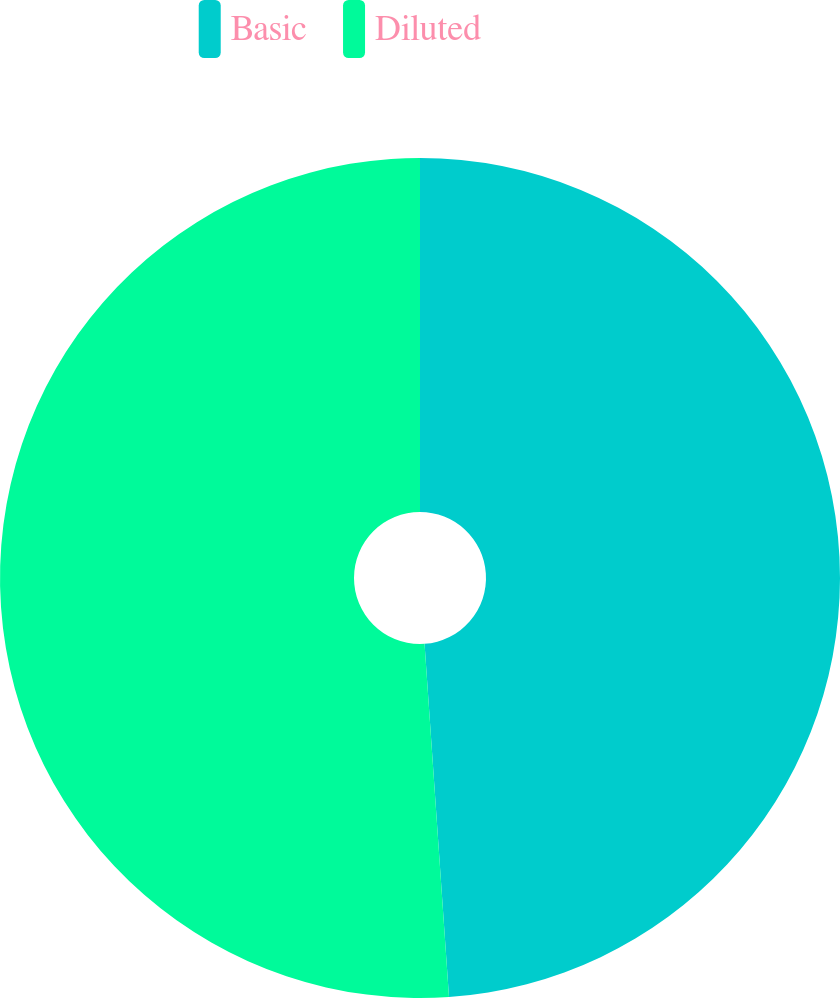Convert chart. <chart><loc_0><loc_0><loc_500><loc_500><pie_chart><fcel>Basic<fcel>Diluted<nl><fcel>48.9%<fcel>51.1%<nl></chart> 